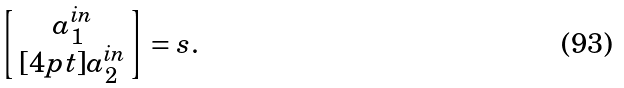<formula> <loc_0><loc_0><loc_500><loc_500>\left [ \, \begin{matrix} a _ { 1 } ^ { \text {in} } \\ [ 4 p t ] a _ { 2 } ^ { \text {in} } \end{matrix} \, \right ] = s .</formula> 